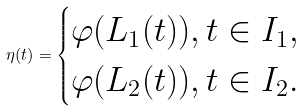<formula> <loc_0><loc_0><loc_500><loc_500>\eta ( t ) = \begin{cases} \varphi ( L _ { 1 } ( t ) ) , t \in I _ { 1 } , \\ \varphi ( L _ { 2 } ( t ) ) , t \in I _ { 2 } . \end{cases}</formula> 